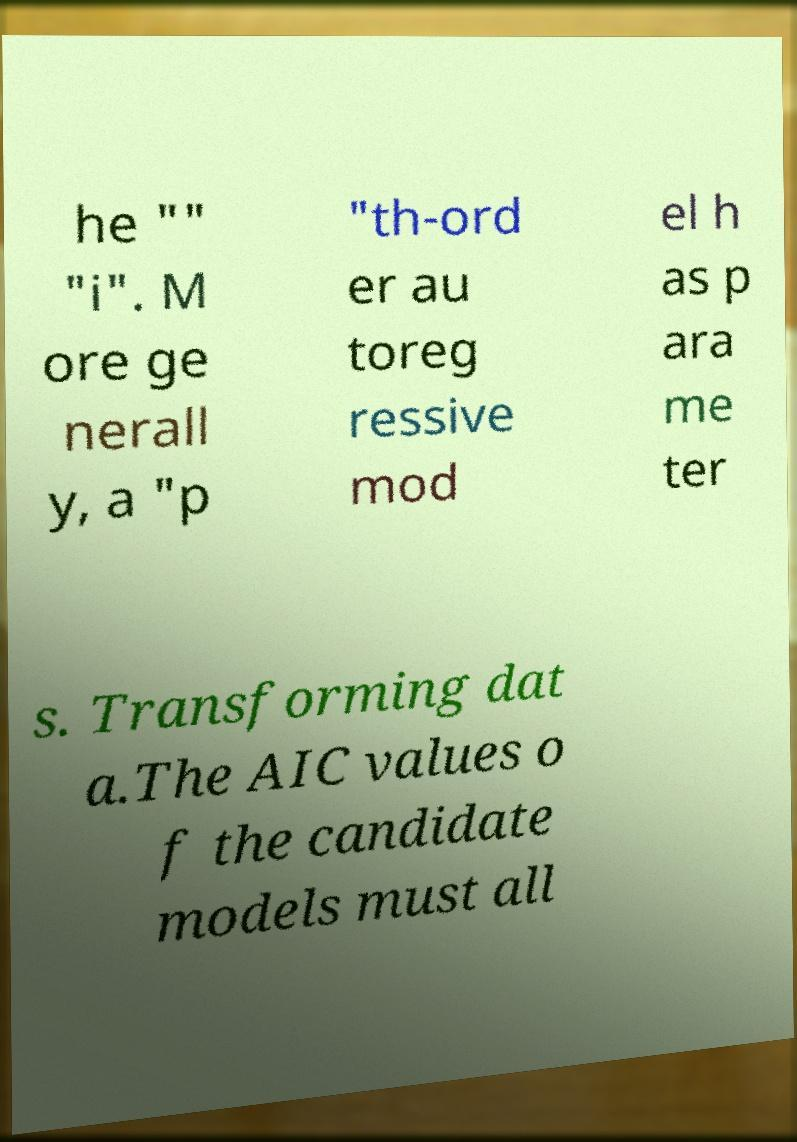I need the written content from this picture converted into text. Can you do that? he "" "i". M ore ge nerall y, a "p "th-ord er au toreg ressive mod el h as p ara me ter s. Transforming dat a.The AIC values o f the candidate models must all 